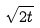<formula> <loc_0><loc_0><loc_500><loc_500>\sqrt { 2 t }</formula> 